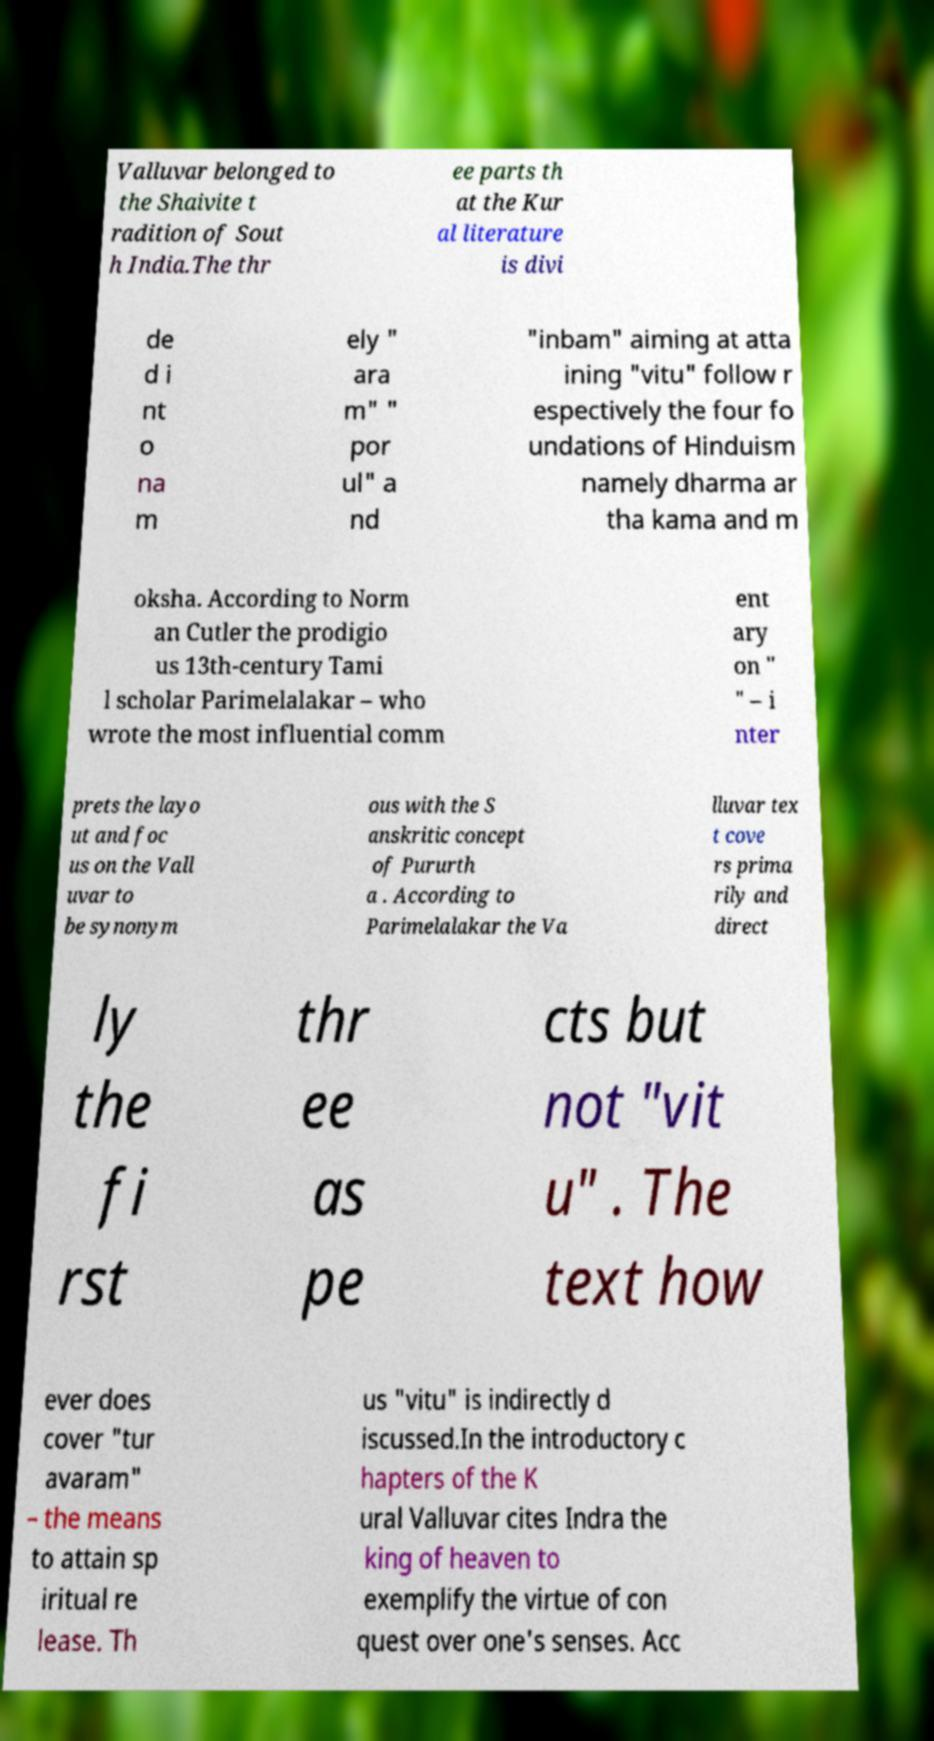Please read and relay the text visible in this image. What does it say? Valluvar belonged to the Shaivite t radition of Sout h India.The thr ee parts th at the Kur al literature is divi de d i nt o na m ely " ara m" " por ul" a nd "inbam" aiming at atta ining "vitu" follow r espectively the four fo undations of Hinduism namely dharma ar tha kama and m oksha. According to Norm an Cutler the prodigio us 13th-century Tami l scholar Parimelalakar – who wrote the most influential comm ent ary on " " – i nter prets the layo ut and foc us on the Vall uvar to be synonym ous with the S anskritic concept of Pururth a . According to Parimelalakar the Va lluvar tex t cove rs prima rily and direct ly the fi rst thr ee as pe cts but not "vit u" . The text how ever does cover "tur avaram" – the means to attain sp iritual re lease. Th us "vitu" is indirectly d iscussed.In the introductory c hapters of the K ural Valluvar cites Indra the king of heaven to exemplify the virtue of con quest over one's senses. Acc 